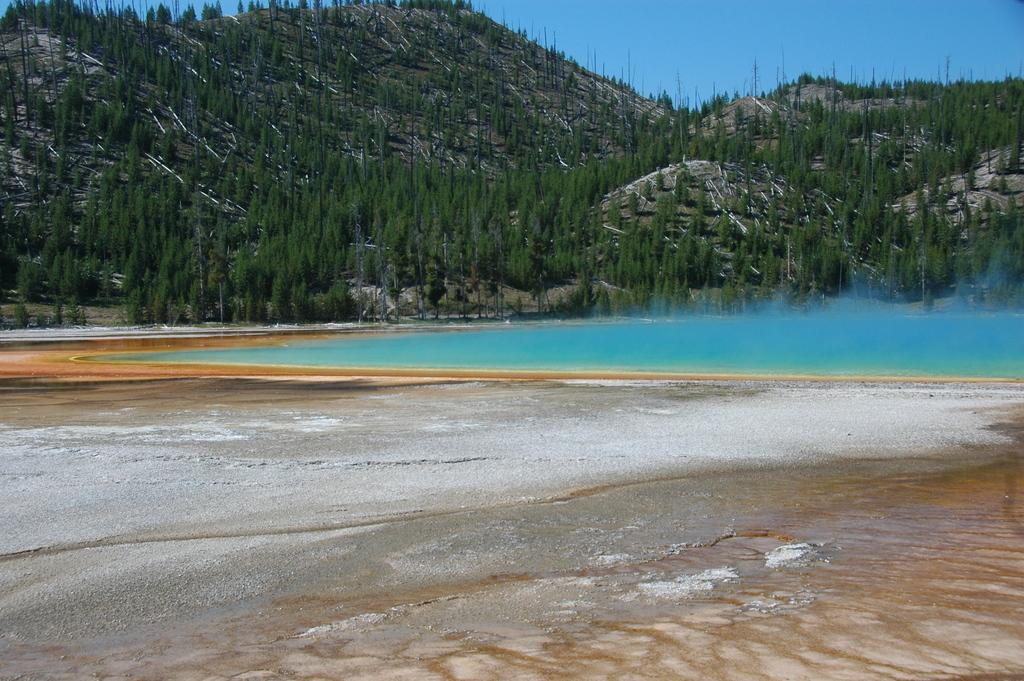What type of natural landscape is depicted in the image? The image features trees on a mountain. What can be seen at the top of the image? The sky is visible at the top of the image. What is present at the bottom of the image? There is water visible at the bottom of the image. What type of terrain is shown in the image? There is sand in the image. What type of eggs are being cooked in the image? There are no eggs or cooking activity present in the image. How is the cream being used in the image? There is no cream present in the image. 